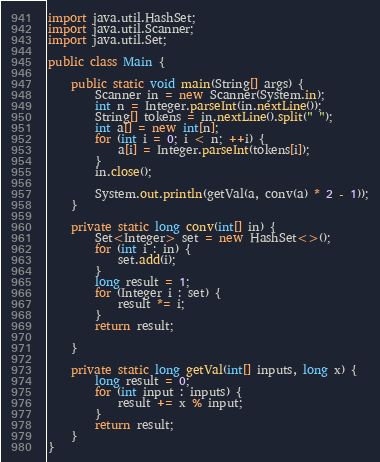Convert code to text. <code><loc_0><loc_0><loc_500><loc_500><_Java_>import java.util.HashSet;
import java.util.Scanner;
import java.util.Set;

public class Main {

	public static void main(String[] args) {
		Scanner in = new Scanner(System.in);
		int n = Integer.parseInt(in.nextLine());
		String[] tokens = in.nextLine().split(" ");
		int a[] = new int[n];
		for (int i = 0; i < n; ++i) {
			a[i] = Integer.parseInt(tokens[i]);
		}
		in.close();

		System.out.println(getVal(a, conv(a) * 2 - 1));
	}

	private static long conv(int[] in) {
		Set<Integer> set = new HashSet<>();
		for (int i : in) {
			set.add(i);
		}
		long result = 1;
		for (Integer i : set) {
			result *= i;
		}
		return result;

	}

	private static long getVal(int[] inputs, long x) {
		long result = 0;
		for (int input : inputs) {
			result += x % input;
		}
		return result;
	}
}</code> 